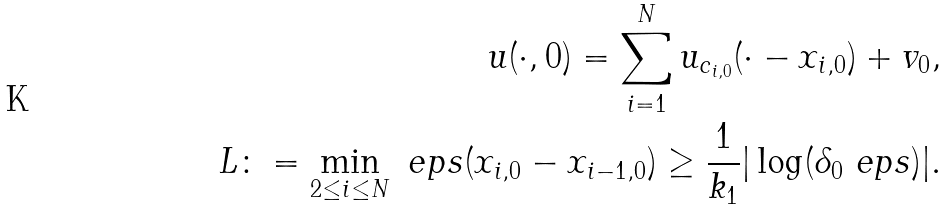<formula> <loc_0><loc_0><loc_500><loc_500>u ( \cdot , 0 ) = \sum _ { i = 1 } ^ { N } u _ { c _ { i , 0 } } ( \cdot - x _ { i , 0 } ) + v _ { 0 } , \\ L \colon = \min _ { 2 \leq i \leq N } \ e p s ( x _ { i , 0 } - x _ { i - 1 , 0 } ) \geq \frac { 1 } { k _ { 1 } } | \log ( \delta _ { 0 } \ e p s ) | .</formula> 